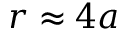Convert formula to latex. <formula><loc_0><loc_0><loc_500><loc_500>r \approx 4 a</formula> 